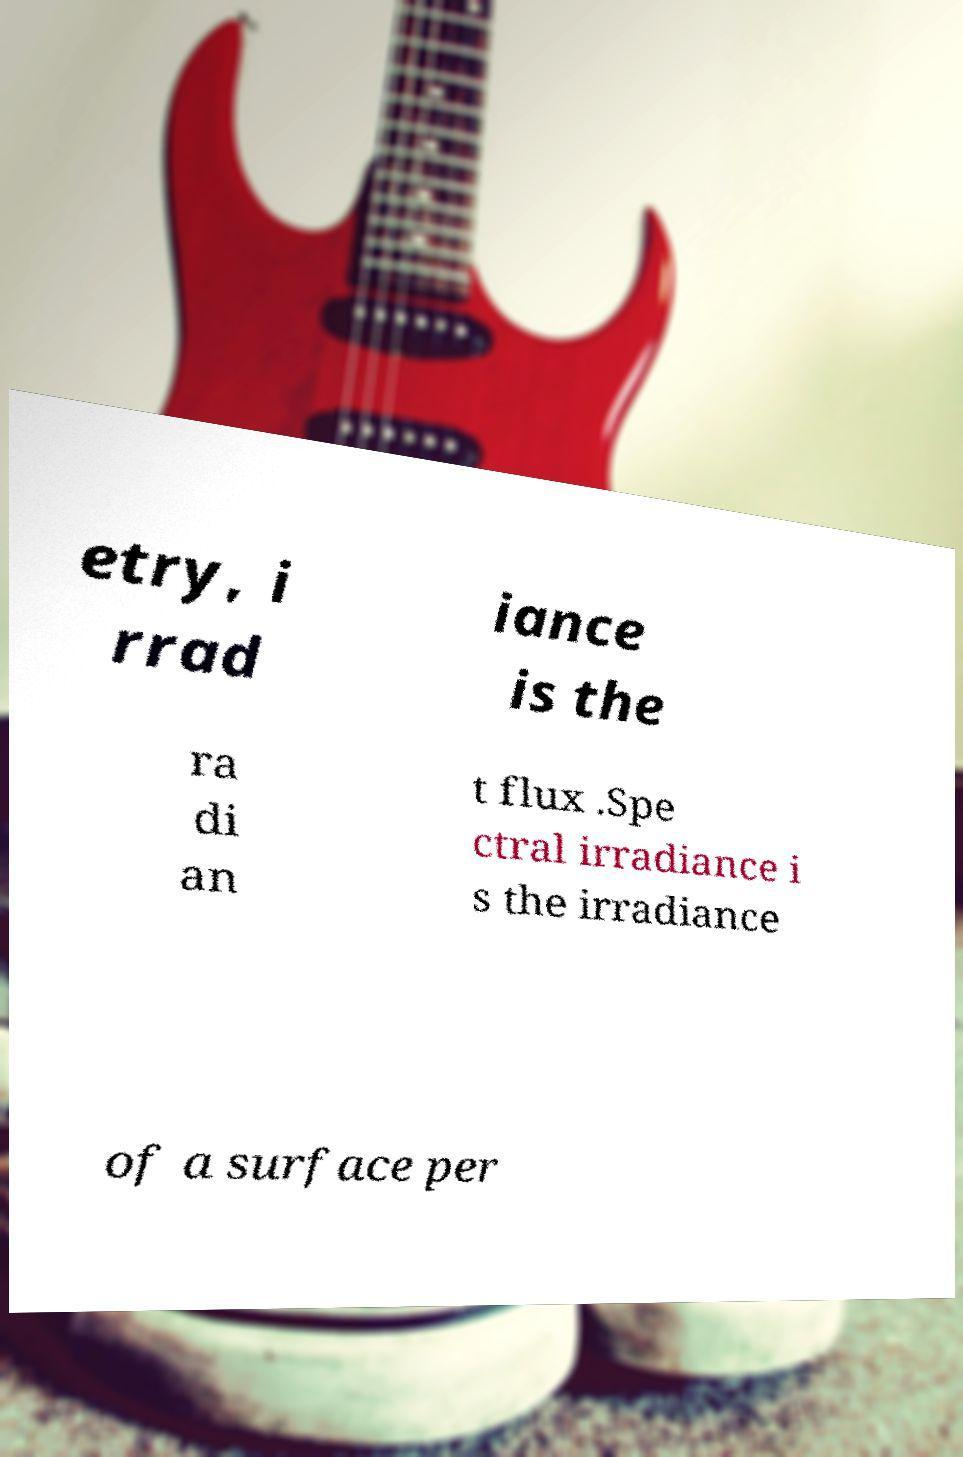Can you accurately transcribe the text from the provided image for me? etry, i rrad iance is the ra di an t flux .Spe ctral irradiance i s the irradiance of a surface per 